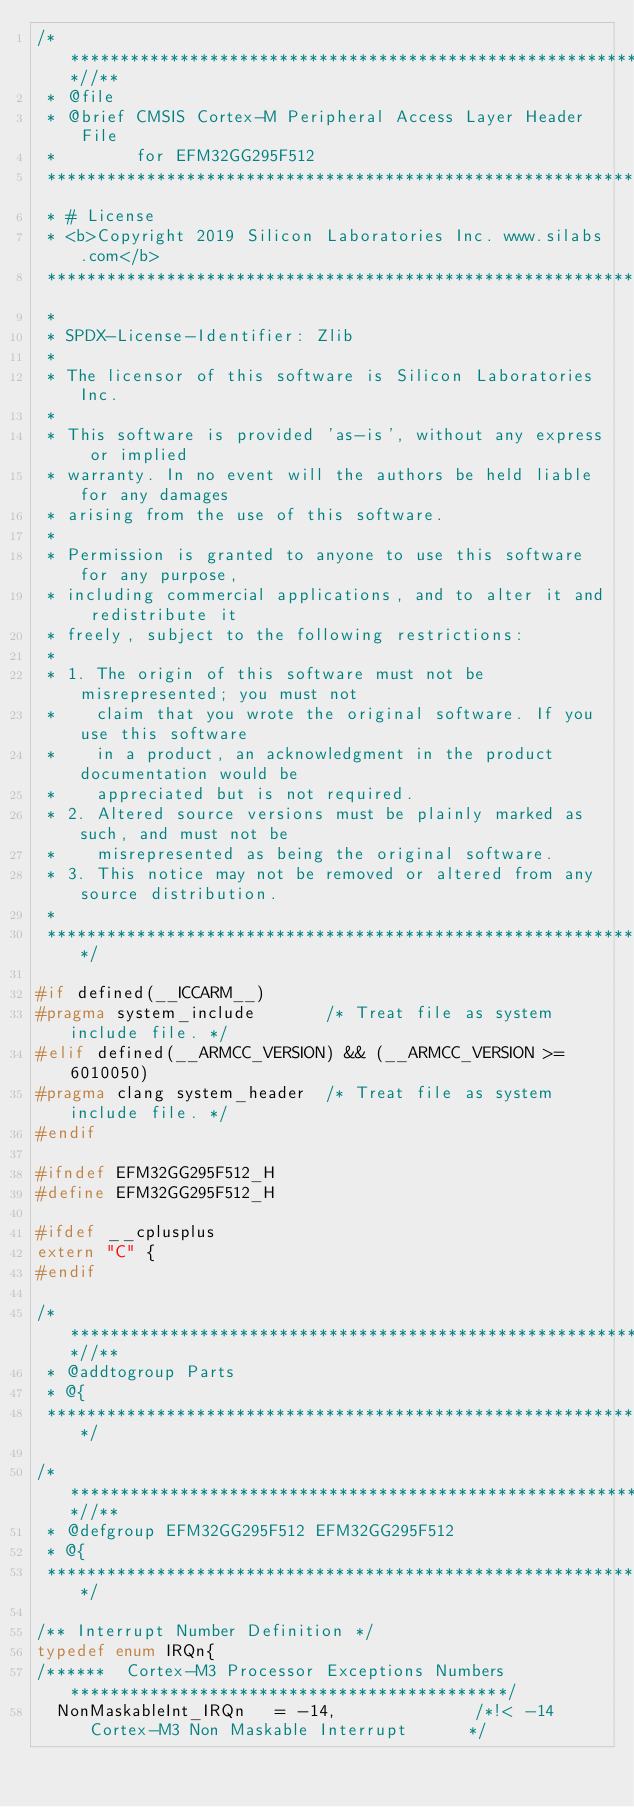<code> <loc_0><loc_0><loc_500><loc_500><_C_>/***************************************************************************//**
 * @file
 * @brief CMSIS Cortex-M Peripheral Access Layer Header File
 *        for EFM32GG295F512
 *******************************************************************************
 * # License
 * <b>Copyright 2019 Silicon Laboratories Inc. www.silabs.com</b>
 *******************************************************************************
 *
 * SPDX-License-Identifier: Zlib
 *
 * The licensor of this software is Silicon Laboratories Inc.
 *
 * This software is provided 'as-is', without any express or implied
 * warranty. In no event will the authors be held liable for any damages
 * arising from the use of this software.
 *
 * Permission is granted to anyone to use this software for any purpose,
 * including commercial applications, and to alter it and redistribute it
 * freely, subject to the following restrictions:
 *
 * 1. The origin of this software must not be misrepresented; you must not
 *    claim that you wrote the original software. If you use this software
 *    in a product, an acknowledgment in the product documentation would be
 *    appreciated but is not required.
 * 2. Altered source versions must be plainly marked as such, and must not be
 *    misrepresented as being the original software.
 * 3. This notice may not be removed or altered from any source distribution.
 *
 ******************************************************************************/

#if defined(__ICCARM__)
#pragma system_include       /* Treat file as system include file. */
#elif defined(__ARMCC_VERSION) && (__ARMCC_VERSION >= 6010050)
#pragma clang system_header  /* Treat file as system include file. */
#endif

#ifndef EFM32GG295F512_H
#define EFM32GG295F512_H

#ifdef __cplusplus
extern "C" {
#endif

/***************************************************************************//**
 * @addtogroup Parts
 * @{
 ******************************************************************************/

/***************************************************************************//**
 * @defgroup EFM32GG295F512 EFM32GG295F512
 * @{
 ******************************************************************************/

/** Interrupt Number Definition */
typedef enum IRQn{
/******  Cortex-M3 Processor Exceptions Numbers ********************************************/
  NonMaskableInt_IRQn   = -14,              /*!< -14 Cortex-M3 Non Maskable Interrupt      */</code> 